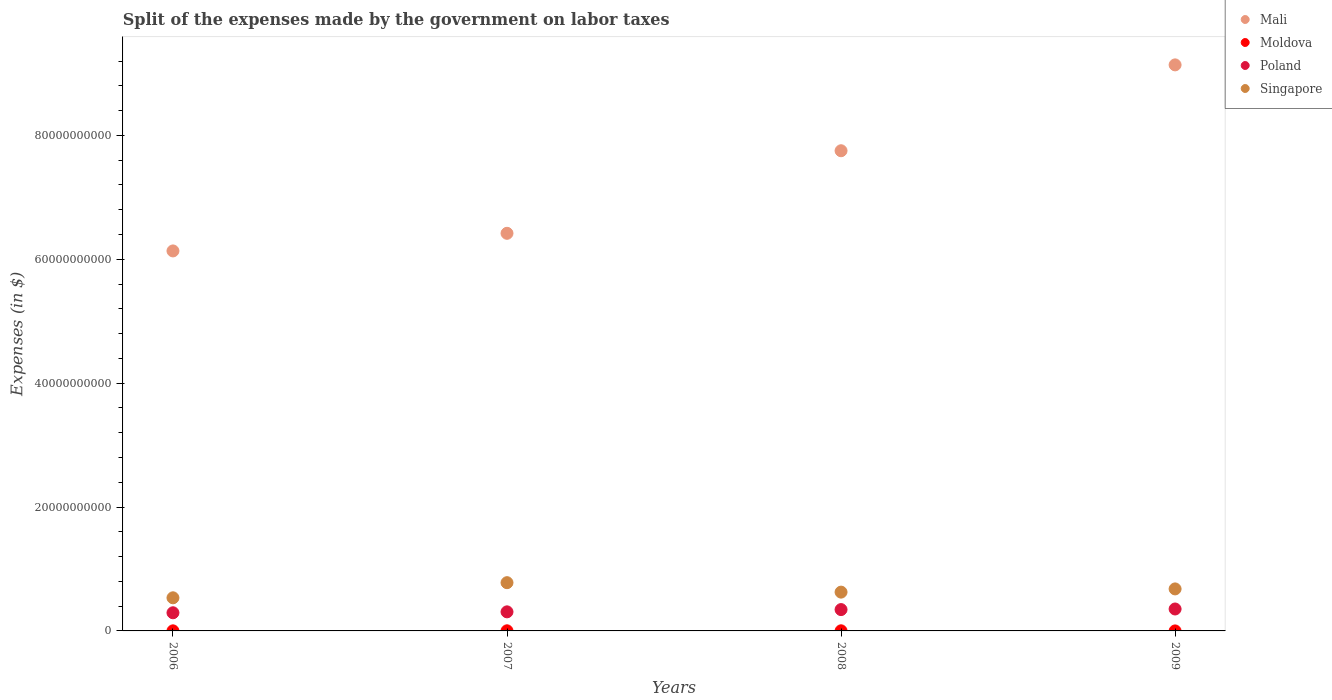What is the expenses made by the government on labor taxes in Poland in 2009?
Provide a succinct answer. 3.54e+09. Across all years, what is the maximum expenses made by the government on labor taxes in Mali?
Offer a terse response. 9.14e+1. Across all years, what is the minimum expenses made by the government on labor taxes in Singapore?
Your answer should be compact. 5.35e+09. In which year was the expenses made by the government on labor taxes in Singapore maximum?
Your response must be concise. 2007. What is the total expenses made by the government on labor taxes in Singapore in the graph?
Your answer should be very brief. 2.62e+1. What is the difference between the expenses made by the government on labor taxes in Poland in 2006 and that in 2008?
Make the answer very short. -5.14e+08. What is the difference between the expenses made by the government on labor taxes in Mali in 2006 and the expenses made by the government on labor taxes in Moldova in 2008?
Make the answer very short. 6.13e+1. What is the average expenses made by the government on labor taxes in Singapore per year?
Provide a short and direct response. 6.55e+09. In the year 2009, what is the difference between the expenses made by the government on labor taxes in Moldova and expenses made by the government on labor taxes in Poland?
Provide a short and direct response. -3.54e+09. What is the ratio of the expenses made by the government on labor taxes in Poland in 2008 to that in 2009?
Offer a very short reply. 0.97. Is the difference between the expenses made by the government on labor taxes in Moldova in 2006 and 2007 greater than the difference between the expenses made by the government on labor taxes in Poland in 2006 and 2007?
Ensure brevity in your answer.  Yes. What is the difference between the highest and the second highest expenses made by the government on labor taxes in Singapore?
Your answer should be compact. 1.01e+09. What is the difference between the highest and the lowest expenses made by the government on labor taxes in Mali?
Your response must be concise. 3.00e+1. In how many years, is the expenses made by the government on labor taxes in Moldova greater than the average expenses made by the government on labor taxes in Moldova taken over all years?
Your answer should be compact. 2. Is it the case that in every year, the sum of the expenses made by the government on labor taxes in Moldova and expenses made by the government on labor taxes in Singapore  is greater than the sum of expenses made by the government on labor taxes in Mali and expenses made by the government on labor taxes in Poland?
Provide a succinct answer. No. Does the expenses made by the government on labor taxes in Poland monotonically increase over the years?
Keep it short and to the point. Yes. Is the expenses made by the government on labor taxes in Poland strictly greater than the expenses made by the government on labor taxes in Singapore over the years?
Make the answer very short. No. How many dotlines are there?
Make the answer very short. 4. How many years are there in the graph?
Keep it short and to the point. 4. Are the values on the major ticks of Y-axis written in scientific E-notation?
Provide a short and direct response. No. Does the graph contain grids?
Give a very brief answer. No. How many legend labels are there?
Keep it short and to the point. 4. How are the legend labels stacked?
Provide a short and direct response. Vertical. What is the title of the graph?
Make the answer very short. Split of the expenses made by the government on labor taxes. What is the label or title of the Y-axis?
Offer a very short reply. Expenses (in $). What is the Expenses (in $) in Mali in 2006?
Offer a very short reply. 6.14e+1. What is the Expenses (in $) in Moldova in 2006?
Your response must be concise. 1.26e+07. What is the Expenses (in $) in Poland in 2006?
Provide a succinct answer. 2.93e+09. What is the Expenses (in $) in Singapore in 2006?
Keep it short and to the point. 5.35e+09. What is the Expenses (in $) of Mali in 2007?
Ensure brevity in your answer.  6.42e+1. What is the Expenses (in $) in Moldova in 2007?
Make the answer very short. 1.90e+07. What is the Expenses (in $) of Poland in 2007?
Your answer should be very brief. 3.08e+09. What is the Expenses (in $) of Singapore in 2007?
Ensure brevity in your answer.  7.79e+09. What is the Expenses (in $) in Mali in 2008?
Ensure brevity in your answer.  7.75e+1. What is the Expenses (in $) of Moldova in 2008?
Provide a short and direct response. 1.86e+07. What is the Expenses (in $) in Poland in 2008?
Offer a terse response. 3.44e+09. What is the Expenses (in $) of Singapore in 2008?
Your answer should be compact. 6.26e+09. What is the Expenses (in $) in Mali in 2009?
Your answer should be very brief. 9.14e+1. What is the Expenses (in $) in Poland in 2009?
Offer a terse response. 3.54e+09. What is the Expenses (in $) of Singapore in 2009?
Provide a short and direct response. 6.78e+09. Across all years, what is the maximum Expenses (in $) in Mali?
Offer a very short reply. 9.14e+1. Across all years, what is the maximum Expenses (in $) in Moldova?
Make the answer very short. 1.90e+07. Across all years, what is the maximum Expenses (in $) of Poland?
Your response must be concise. 3.54e+09. Across all years, what is the maximum Expenses (in $) of Singapore?
Make the answer very short. 7.79e+09. Across all years, what is the minimum Expenses (in $) in Mali?
Give a very brief answer. 6.14e+1. Across all years, what is the minimum Expenses (in $) in Moldova?
Your answer should be compact. 5.00e+05. Across all years, what is the minimum Expenses (in $) of Poland?
Keep it short and to the point. 2.93e+09. Across all years, what is the minimum Expenses (in $) of Singapore?
Make the answer very short. 5.35e+09. What is the total Expenses (in $) in Mali in the graph?
Provide a short and direct response. 2.94e+11. What is the total Expenses (in $) in Moldova in the graph?
Keep it short and to the point. 5.07e+07. What is the total Expenses (in $) of Poland in the graph?
Your response must be concise. 1.30e+1. What is the total Expenses (in $) of Singapore in the graph?
Your response must be concise. 2.62e+1. What is the difference between the Expenses (in $) of Mali in 2006 and that in 2007?
Offer a terse response. -2.84e+09. What is the difference between the Expenses (in $) in Moldova in 2006 and that in 2007?
Keep it short and to the point. -6.40e+06. What is the difference between the Expenses (in $) of Poland in 2006 and that in 2007?
Your response must be concise. -1.49e+08. What is the difference between the Expenses (in $) in Singapore in 2006 and that in 2007?
Offer a terse response. -2.44e+09. What is the difference between the Expenses (in $) of Mali in 2006 and that in 2008?
Ensure brevity in your answer.  -1.62e+1. What is the difference between the Expenses (in $) in Moldova in 2006 and that in 2008?
Your response must be concise. -6.00e+06. What is the difference between the Expenses (in $) in Poland in 2006 and that in 2008?
Provide a short and direct response. -5.14e+08. What is the difference between the Expenses (in $) of Singapore in 2006 and that in 2008?
Your answer should be very brief. -9.17e+08. What is the difference between the Expenses (in $) in Mali in 2006 and that in 2009?
Your answer should be very brief. -3.00e+1. What is the difference between the Expenses (in $) of Moldova in 2006 and that in 2009?
Give a very brief answer. 1.21e+07. What is the difference between the Expenses (in $) in Poland in 2006 and that in 2009?
Your answer should be compact. -6.09e+08. What is the difference between the Expenses (in $) in Singapore in 2006 and that in 2009?
Provide a short and direct response. -1.44e+09. What is the difference between the Expenses (in $) in Mali in 2007 and that in 2008?
Your response must be concise. -1.33e+1. What is the difference between the Expenses (in $) in Poland in 2007 and that in 2008?
Offer a very short reply. -3.65e+08. What is the difference between the Expenses (in $) of Singapore in 2007 and that in 2008?
Keep it short and to the point. 1.53e+09. What is the difference between the Expenses (in $) of Mali in 2007 and that in 2009?
Provide a short and direct response. -2.72e+1. What is the difference between the Expenses (in $) of Moldova in 2007 and that in 2009?
Your response must be concise. 1.85e+07. What is the difference between the Expenses (in $) of Poland in 2007 and that in 2009?
Provide a short and direct response. -4.60e+08. What is the difference between the Expenses (in $) of Singapore in 2007 and that in 2009?
Offer a very short reply. 1.01e+09. What is the difference between the Expenses (in $) in Mali in 2008 and that in 2009?
Provide a short and direct response. -1.39e+1. What is the difference between the Expenses (in $) in Moldova in 2008 and that in 2009?
Make the answer very short. 1.81e+07. What is the difference between the Expenses (in $) of Poland in 2008 and that in 2009?
Make the answer very short. -9.50e+07. What is the difference between the Expenses (in $) of Singapore in 2008 and that in 2009?
Give a very brief answer. -5.19e+08. What is the difference between the Expenses (in $) in Mali in 2006 and the Expenses (in $) in Moldova in 2007?
Offer a very short reply. 6.13e+1. What is the difference between the Expenses (in $) in Mali in 2006 and the Expenses (in $) in Poland in 2007?
Provide a succinct answer. 5.83e+1. What is the difference between the Expenses (in $) of Mali in 2006 and the Expenses (in $) of Singapore in 2007?
Give a very brief answer. 5.36e+1. What is the difference between the Expenses (in $) in Moldova in 2006 and the Expenses (in $) in Poland in 2007?
Your answer should be very brief. -3.07e+09. What is the difference between the Expenses (in $) of Moldova in 2006 and the Expenses (in $) of Singapore in 2007?
Give a very brief answer. -7.78e+09. What is the difference between the Expenses (in $) of Poland in 2006 and the Expenses (in $) of Singapore in 2007?
Make the answer very short. -4.86e+09. What is the difference between the Expenses (in $) in Mali in 2006 and the Expenses (in $) in Moldova in 2008?
Make the answer very short. 6.13e+1. What is the difference between the Expenses (in $) of Mali in 2006 and the Expenses (in $) of Poland in 2008?
Give a very brief answer. 5.79e+1. What is the difference between the Expenses (in $) in Mali in 2006 and the Expenses (in $) in Singapore in 2008?
Make the answer very short. 5.51e+1. What is the difference between the Expenses (in $) of Moldova in 2006 and the Expenses (in $) of Poland in 2008?
Offer a very short reply. -3.43e+09. What is the difference between the Expenses (in $) of Moldova in 2006 and the Expenses (in $) of Singapore in 2008?
Keep it short and to the point. -6.25e+09. What is the difference between the Expenses (in $) in Poland in 2006 and the Expenses (in $) in Singapore in 2008?
Provide a succinct answer. -3.33e+09. What is the difference between the Expenses (in $) of Mali in 2006 and the Expenses (in $) of Moldova in 2009?
Offer a very short reply. 6.14e+1. What is the difference between the Expenses (in $) in Mali in 2006 and the Expenses (in $) in Poland in 2009?
Ensure brevity in your answer.  5.78e+1. What is the difference between the Expenses (in $) in Mali in 2006 and the Expenses (in $) in Singapore in 2009?
Keep it short and to the point. 5.46e+1. What is the difference between the Expenses (in $) in Moldova in 2006 and the Expenses (in $) in Poland in 2009?
Give a very brief answer. -3.53e+09. What is the difference between the Expenses (in $) of Moldova in 2006 and the Expenses (in $) of Singapore in 2009?
Offer a very short reply. -6.77e+09. What is the difference between the Expenses (in $) in Poland in 2006 and the Expenses (in $) in Singapore in 2009?
Your response must be concise. -3.85e+09. What is the difference between the Expenses (in $) in Mali in 2007 and the Expenses (in $) in Moldova in 2008?
Provide a succinct answer. 6.42e+1. What is the difference between the Expenses (in $) of Mali in 2007 and the Expenses (in $) of Poland in 2008?
Offer a very short reply. 6.08e+1. What is the difference between the Expenses (in $) in Mali in 2007 and the Expenses (in $) in Singapore in 2008?
Provide a short and direct response. 5.79e+1. What is the difference between the Expenses (in $) of Moldova in 2007 and the Expenses (in $) of Poland in 2008?
Your answer should be very brief. -3.43e+09. What is the difference between the Expenses (in $) of Moldova in 2007 and the Expenses (in $) of Singapore in 2008?
Your answer should be very brief. -6.24e+09. What is the difference between the Expenses (in $) in Poland in 2007 and the Expenses (in $) in Singapore in 2008?
Your answer should be very brief. -3.18e+09. What is the difference between the Expenses (in $) in Mali in 2007 and the Expenses (in $) in Moldova in 2009?
Make the answer very short. 6.42e+1. What is the difference between the Expenses (in $) in Mali in 2007 and the Expenses (in $) in Poland in 2009?
Offer a terse response. 6.07e+1. What is the difference between the Expenses (in $) in Mali in 2007 and the Expenses (in $) in Singapore in 2009?
Your answer should be very brief. 5.74e+1. What is the difference between the Expenses (in $) in Moldova in 2007 and the Expenses (in $) in Poland in 2009?
Make the answer very short. -3.52e+09. What is the difference between the Expenses (in $) in Moldova in 2007 and the Expenses (in $) in Singapore in 2009?
Offer a very short reply. -6.76e+09. What is the difference between the Expenses (in $) in Poland in 2007 and the Expenses (in $) in Singapore in 2009?
Make the answer very short. -3.70e+09. What is the difference between the Expenses (in $) in Mali in 2008 and the Expenses (in $) in Moldova in 2009?
Keep it short and to the point. 7.75e+1. What is the difference between the Expenses (in $) of Mali in 2008 and the Expenses (in $) of Poland in 2009?
Ensure brevity in your answer.  7.40e+1. What is the difference between the Expenses (in $) of Mali in 2008 and the Expenses (in $) of Singapore in 2009?
Your answer should be compact. 7.07e+1. What is the difference between the Expenses (in $) of Moldova in 2008 and the Expenses (in $) of Poland in 2009?
Your answer should be compact. -3.52e+09. What is the difference between the Expenses (in $) of Moldova in 2008 and the Expenses (in $) of Singapore in 2009?
Keep it short and to the point. -6.76e+09. What is the difference between the Expenses (in $) of Poland in 2008 and the Expenses (in $) of Singapore in 2009?
Make the answer very short. -3.34e+09. What is the average Expenses (in $) of Mali per year?
Keep it short and to the point. 7.36e+1. What is the average Expenses (in $) of Moldova per year?
Ensure brevity in your answer.  1.27e+07. What is the average Expenses (in $) of Poland per year?
Ensure brevity in your answer.  3.25e+09. What is the average Expenses (in $) of Singapore per year?
Your answer should be very brief. 6.55e+09. In the year 2006, what is the difference between the Expenses (in $) in Mali and Expenses (in $) in Moldova?
Make the answer very short. 6.13e+1. In the year 2006, what is the difference between the Expenses (in $) of Mali and Expenses (in $) of Poland?
Your answer should be compact. 5.84e+1. In the year 2006, what is the difference between the Expenses (in $) of Mali and Expenses (in $) of Singapore?
Give a very brief answer. 5.60e+1. In the year 2006, what is the difference between the Expenses (in $) of Moldova and Expenses (in $) of Poland?
Your response must be concise. -2.92e+09. In the year 2006, what is the difference between the Expenses (in $) of Moldova and Expenses (in $) of Singapore?
Your response must be concise. -5.33e+09. In the year 2006, what is the difference between the Expenses (in $) in Poland and Expenses (in $) in Singapore?
Make the answer very short. -2.42e+09. In the year 2007, what is the difference between the Expenses (in $) in Mali and Expenses (in $) in Moldova?
Provide a succinct answer. 6.42e+1. In the year 2007, what is the difference between the Expenses (in $) in Mali and Expenses (in $) in Poland?
Provide a succinct answer. 6.11e+1. In the year 2007, what is the difference between the Expenses (in $) of Mali and Expenses (in $) of Singapore?
Offer a terse response. 5.64e+1. In the year 2007, what is the difference between the Expenses (in $) in Moldova and Expenses (in $) in Poland?
Ensure brevity in your answer.  -3.06e+09. In the year 2007, what is the difference between the Expenses (in $) of Moldova and Expenses (in $) of Singapore?
Give a very brief answer. -7.77e+09. In the year 2007, what is the difference between the Expenses (in $) of Poland and Expenses (in $) of Singapore?
Provide a short and direct response. -4.71e+09. In the year 2008, what is the difference between the Expenses (in $) of Mali and Expenses (in $) of Moldova?
Your response must be concise. 7.75e+1. In the year 2008, what is the difference between the Expenses (in $) in Mali and Expenses (in $) in Poland?
Your response must be concise. 7.41e+1. In the year 2008, what is the difference between the Expenses (in $) in Mali and Expenses (in $) in Singapore?
Offer a very short reply. 7.13e+1. In the year 2008, what is the difference between the Expenses (in $) in Moldova and Expenses (in $) in Poland?
Your answer should be compact. -3.43e+09. In the year 2008, what is the difference between the Expenses (in $) in Moldova and Expenses (in $) in Singapore?
Keep it short and to the point. -6.25e+09. In the year 2008, what is the difference between the Expenses (in $) of Poland and Expenses (in $) of Singapore?
Your answer should be compact. -2.82e+09. In the year 2009, what is the difference between the Expenses (in $) of Mali and Expenses (in $) of Moldova?
Your answer should be compact. 9.14e+1. In the year 2009, what is the difference between the Expenses (in $) in Mali and Expenses (in $) in Poland?
Ensure brevity in your answer.  8.79e+1. In the year 2009, what is the difference between the Expenses (in $) in Mali and Expenses (in $) in Singapore?
Keep it short and to the point. 8.46e+1. In the year 2009, what is the difference between the Expenses (in $) of Moldova and Expenses (in $) of Poland?
Ensure brevity in your answer.  -3.54e+09. In the year 2009, what is the difference between the Expenses (in $) of Moldova and Expenses (in $) of Singapore?
Give a very brief answer. -6.78e+09. In the year 2009, what is the difference between the Expenses (in $) of Poland and Expenses (in $) of Singapore?
Your answer should be very brief. -3.24e+09. What is the ratio of the Expenses (in $) in Mali in 2006 to that in 2007?
Ensure brevity in your answer.  0.96. What is the ratio of the Expenses (in $) in Moldova in 2006 to that in 2007?
Keep it short and to the point. 0.66. What is the ratio of the Expenses (in $) of Poland in 2006 to that in 2007?
Offer a very short reply. 0.95. What is the ratio of the Expenses (in $) in Singapore in 2006 to that in 2007?
Keep it short and to the point. 0.69. What is the ratio of the Expenses (in $) of Mali in 2006 to that in 2008?
Offer a very short reply. 0.79. What is the ratio of the Expenses (in $) in Moldova in 2006 to that in 2008?
Provide a short and direct response. 0.68. What is the ratio of the Expenses (in $) in Poland in 2006 to that in 2008?
Give a very brief answer. 0.85. What is the ratio of the Expenses (in $) in Singapore in 2006 to that in 2008?
Make the answer very short. 0.85. What is the ratio of the Expenses (in $) in Mali in 2006 to that in 2009?
Ensure brevity in your answer.  0.67. What is the ratio of the Expenses (in $) of Moldova in 2006 to that in 2009?
Offer a terse response. 25.2. What is the ratio of the Expenses (in $) of Poland in 2006 to that in 2009?
Keep it short and to the point. 0.83. What is the ratio of the Expenses (in $) in Singapore in 2006 to that in 2009?
Provide a succinct answer. 0.79. What is the ratio of the Expenses (in $) of Mali in 2007 to that in 2008?
Provide a short and direct response. 0.83. What is the ratio of the Expenses (in $) of Moldova in 2007 to that in 2008?
Provide a succinct answer. 1.02. What is the ratio of the Expenses (in $) in Poland in 2007 to that in 2008?
Your response must be concise. 0.89. What is the ratio of the Expenses (in $) in Singapore in 2007 to that in 2008?
Offer a terse response. 1.24. What is the ratio of the Expenses (in $) of Mali in 2007 to that in 2009?
Your answer should be compact. 0.7. What is the ratio of the Expenses (in $) of Moldova in 2007 to that in 2009?
Give a very brief answer. 38. What is the ratio of the Expenses (in $) in Poland in 2007 to that in 2009?
Provide a short and direct response. 0.87. What is the ratio of the Expenses (in $) of Singapore in 2007 to that in 2009?
Provide a short and direct response. 1.15. What is the ratio of the Expenses (in $) in Mali in 2008 to that in 2009?
Provide a succinct answer. 0.85. What is the ratio of the Expenses (in $) in Moldova in 2008 to that in 2009?
Keep it short and to the point. 37.2. What is the ratio of the Expenses (in $) in Poland in 2008 to that in 2009?
Keep it short and to the point. 0.97. What is the ratio of the Expenses (in $) in Singapore in 2008 to that in 2009?
Make the answer very short. 0.92. What is the difference between the highest and the second highest Expenses (in $) in Mali?
Ensure brevity in your answer.  1.39e+1. What is the difference between the highest and the second highest Expenses (in $) of Moldova?
Provide a succinct answer. 4.00e+05. What is the difference between the highest and the second highest Expenses (in $) in Poland?
Offer a terse response. 9.50e+07. What is the difference between the highest and the second highest Expenses (in $) of Singapore?
Your answer should be compact. 1.01e+09. What is the difference between the highest and the lowest Expenses (in $) of Mali?
Your answer should be compact. 3.00e+1. What is the difference between the highest and the lowest Expenses (in $) in Moldova?
Your response must be concise. 1.85e+07. What is the difference between the highest and the lowest Expenses (in $) in Poland?
Give a very brief answer. 6.09e+08. What is the difference between the highest and the lowest Expenses (in $) in Singapore?
Make the answer very short. 2.44e+09. 